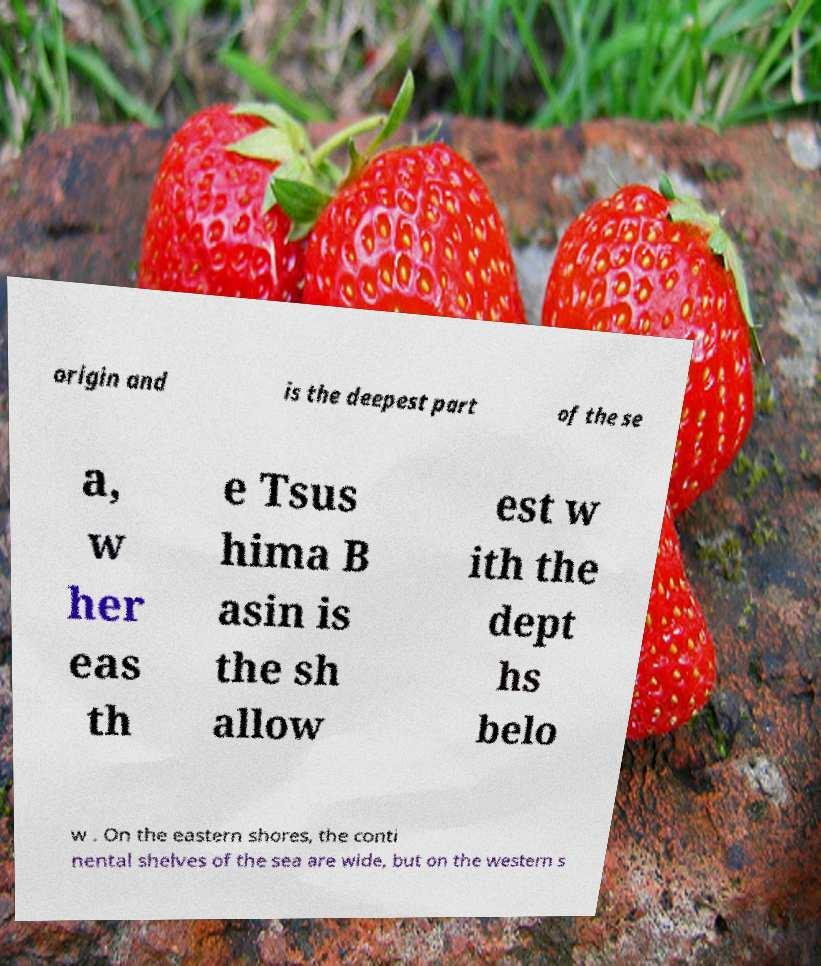Could you extract and type out the text from this image? origin and is the deepest part of the se a, w her eas th e Tsus hima B asin is the sh allow est w ith the dept hs belo w . On the eastern shores, the conti nental shelves of the sea are wide, but on the western s 